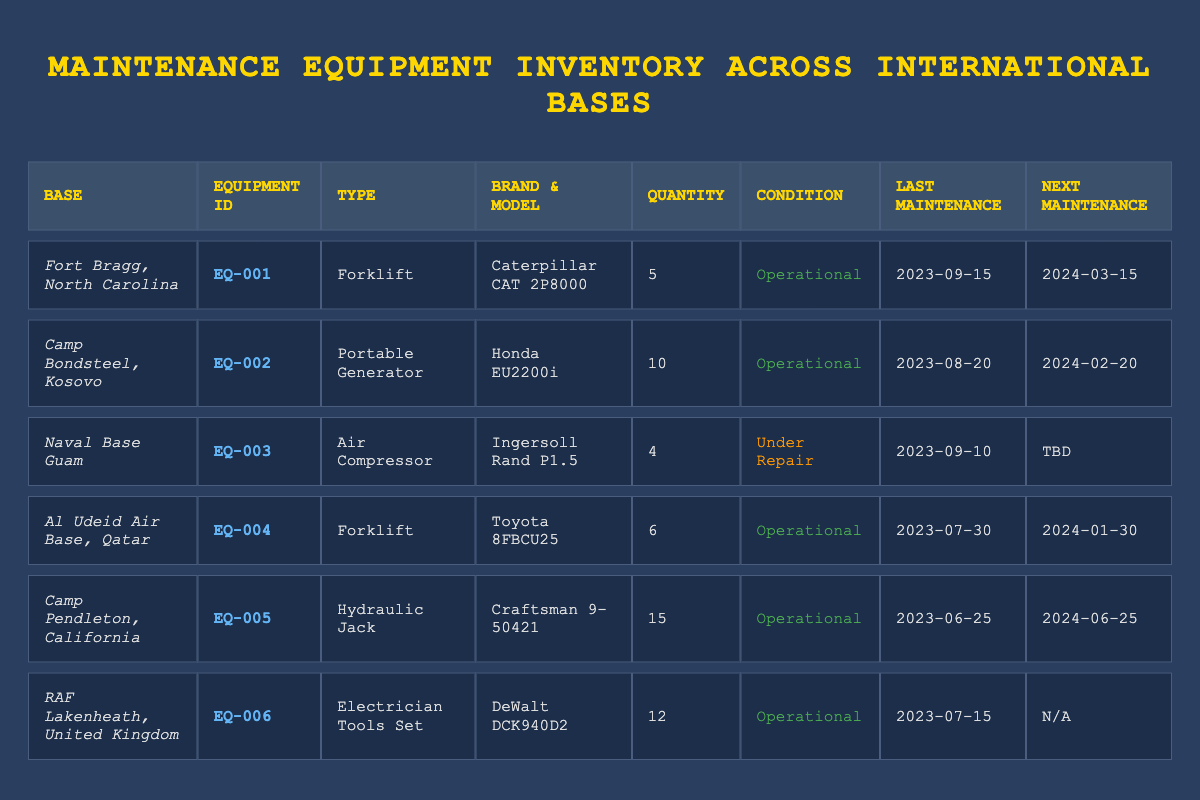What is the total quantity of operational forklifts across all bases? From the table, there are two operational forklifts: one at Fort Bragg with a quantity of 5 and one at Al Udeid Air Base with a quantity of 6. Adding these together gives us a total of 5 + 6 = 11 operational forklifts.
Answer: 11 Which base has the largest number of maintenance equipment? By examining the Quantity column, Camp Pendleton has the highest quantity at 15, which is more than any other base.
Answer: Camp Pendleton, California Is the air compressor at Naval Base Guam operational? The condition of the air compressor at Naval Base Guam is listed as "Under Repair," indicating it is not operational.
Answer: No When is the next maintenance due for the portable generator at Camp Bondsteel? Looking at the entry for the portable generator in the table, the next maintenance date is listed as February 20, 2024.
Answer: 2024-02-20 How many pieces of equipment are currently under repair? The only equipment listed under repair is the air compressor at Naval Base Guam, which totals one piece of equipment currently under repair.
Answer: 1 Which base has the equipment with the earliest last maintenance date? By reviewing the Last Maintenance Date column, Fort Bragg has the earliest last maintenance date of September 15, 2023, compared to other bases.
Answer: Fort Bragg, North Carolina What is the total quantity of electrician tool sets across all bases? The table lists one type of equipment, the Electrician Tools Set, located at RAF Lakenheath with a quantity of 12. Therefore, the total is simply 12.
Answer: 12 Are all maintenance equipment in operational condition? By reviewing the Condition column, the air compressor at Naval Base Guam is the only equipment not operational as it is under repair. Thus, not all equipment is operational.
Answer: No What is the average quantity of maintenance equipment per base? There are 6 bases and the total quantity of equipment is 5 (Forklift) + 10 (Portable Generator) + 4 (Air Compressor) + 6 (Forklift) + 15 (Hydraulic Jack) + 12 (Electrician Tools Set) = 52. Dividing this by 6 bases, we get an average of 52 / 6 = approximately 8.67, or rounded to 9 for practical purposes.
Answer: 9 